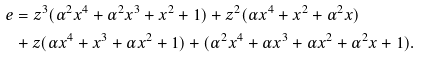<formula> <loc_0><loc_0><loc_500><loc_500>e & = z ^ { 3 } ( \alpha ^ { 2 } x ^ { 4 } + \alpha ^ { 2 } x ^ { 3 } + x ^ { 2 } + 1 ) + z ^ { 2 } ( \alpha x ^ { 4 } + x ^ { 2 } + \alpha ^ { 2 } x ) \\ & + z ( \alpha x ^ { 4 } + x ^ { 3 } + \alpha x ^ { 2 } + 1 ) + ( \alpha ^ { 2 } x ^ { 4 } + \alpha x ^ { 3 } + \alpha x ^ { 2 } + \alpha ^ { 2 } x + 1 ) .</formula> 